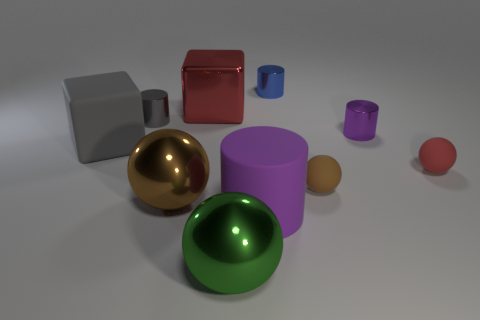Which objects in the image seem to be reflecting light most intensely? The shiny golden ball and the red cube reflect light with the most intensity, indicating they have highly reflective surfaces. How could the position of the light source be inferred from the reflections? The position of the light source can be inferred by observing the brightest spots on the reflective objects and determining the angle of incidence, which suggests the light is coming from the upper left of the scene. 